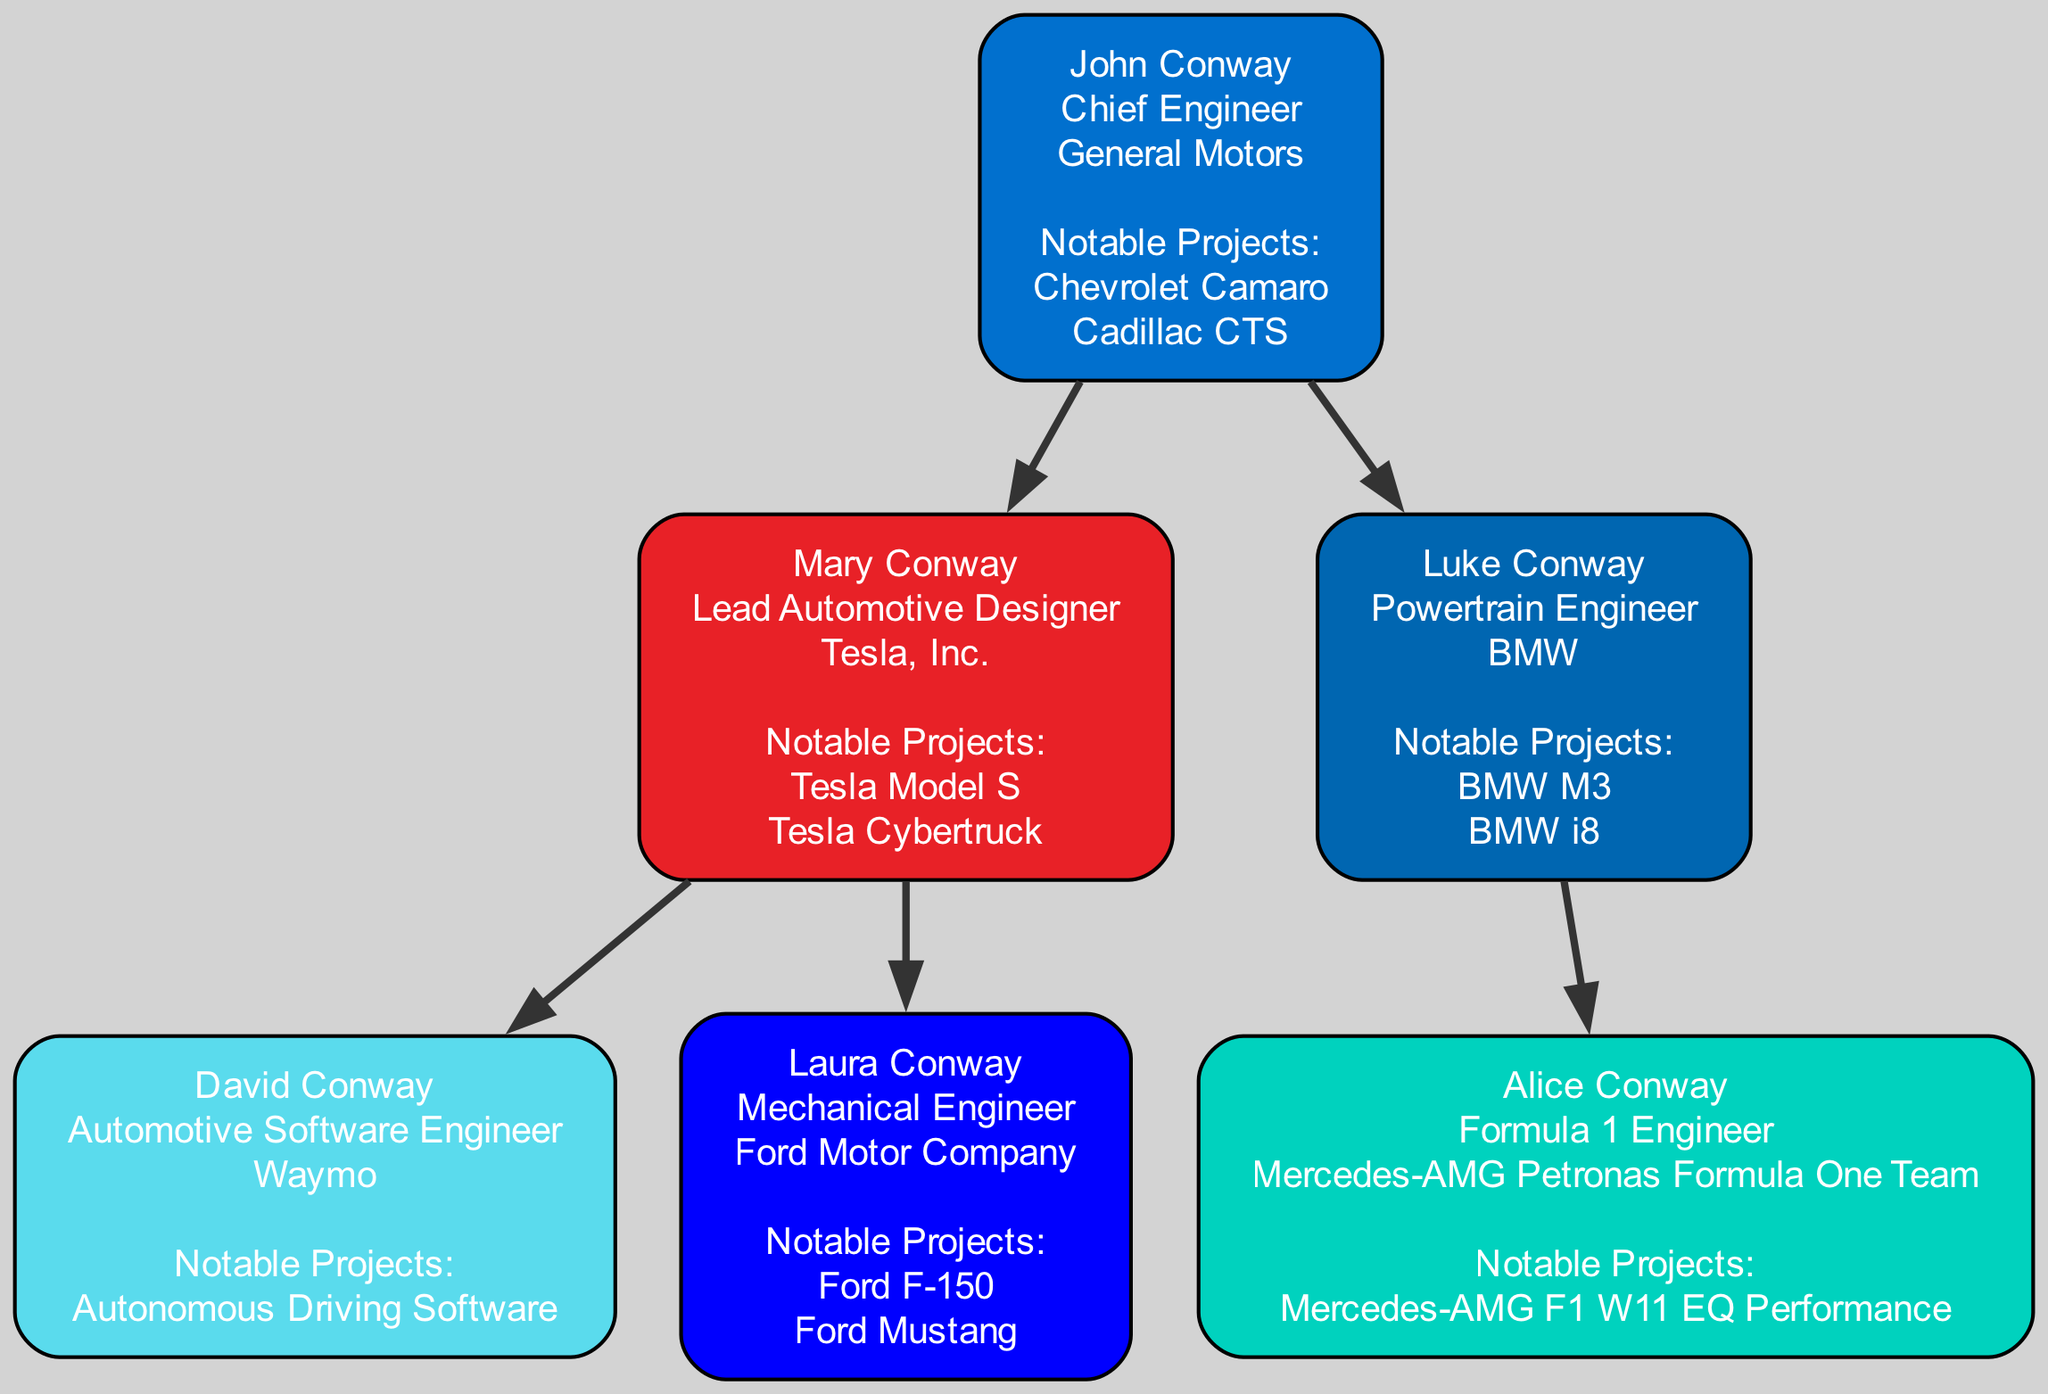What is John Conway's career position? The diagram indicates that John Conway is the Chief Engineer at General Motors. This information can be found directly in the career section associated with his node.
Answer: Chief Engineer Which notable project is associated with Luke Conway? In the diagram, Luke Conway has been linked to two notable projects: BMW M3 and BMW i8. These projects are listed under his career information, indicating his work as a Powertrain Engineer at BMW.
Answer: BMW M3 How many children does Mary Conway have? Mary Conway is shown to have two children in the diagram: David Conway and Laura Conway. This is evidenced by the immediate family structure depicted under her node.
Answer: 2 Which company employs David Conway? According to the diagram, David Conway works at Waymo as an Automotive Software Engineer. This detail is found right under his name in the career section.
Answer: Waymo What is the career position of Alice Conway? The diagram presents Alice Conway’s position as a Formula 1 Engineer at the Mercedes-AMG Petronas Formula One Team. This information is clearly displayed under her node.
Answer: Formula 1 Engineer Who is the parent of Laura Conway? The diagram illustrates that Laura Conway is a child of Mary Conway. This relationship can be traced up the family tree from Laura’s node to her mother’s node.
Answer: Mary Conway What notable projects did John Conway work on? John Conway is highlighted as having worked on two notable projects: Chevrolet Camaro and Cadillac CTS. These projects can be seen in the notable projects section of his node.
Answer: Chevrolet Camaro, Cadillac CTS How many distinct engineers are depicted in the family tree? By counting all individuals involved—John, Mary, David, Laura, Luke, and Alice Conway—the diagram shows a total of six engineers represented in the family tree.
Answer: 6 Which engineer has the highest company profile? Mary Conway, as the Lead Automotive Designer at Tesla, Inc., is arguably represented with a higher profile given Tesla’s prominence in the automotive industry and her notable projects of Model S and Cybertruck.
Answer: Mary Conway 